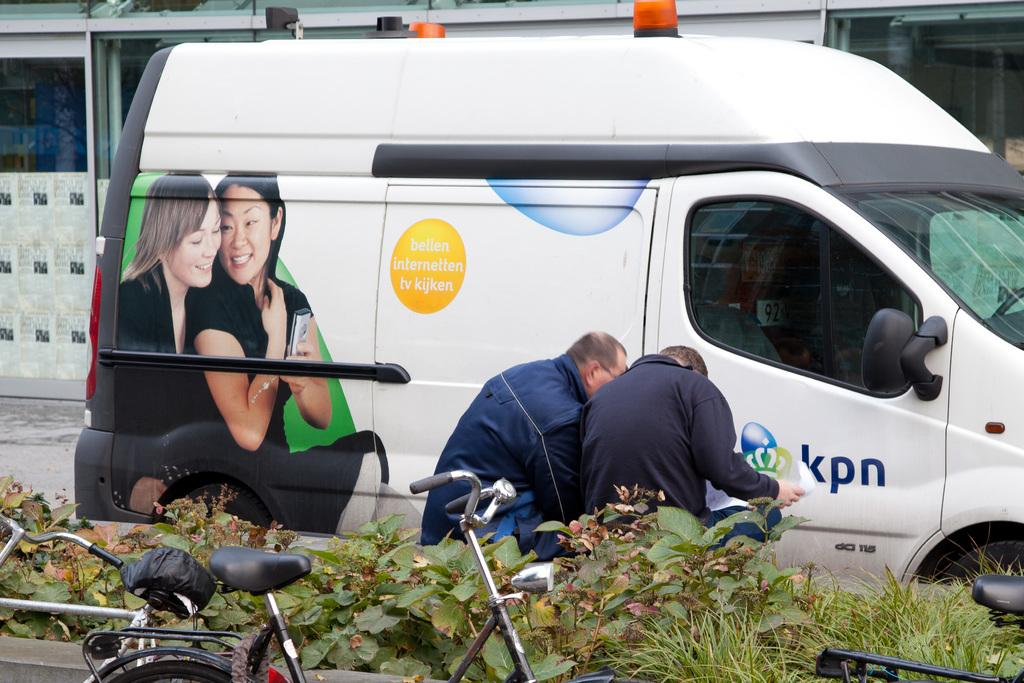<image>
Relay a brief, clear account of the picture shown. a kpn sign on the side of a van 